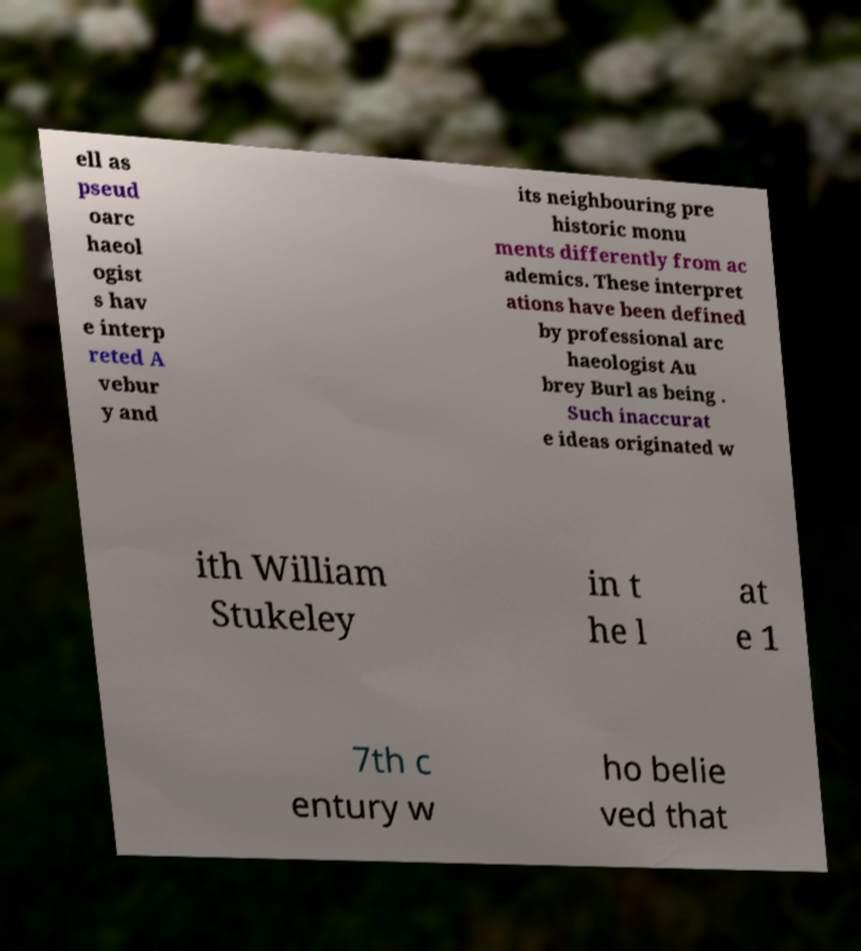Can you read and provide the text displayed in the image?This photo seems to have some interesting text. Can you extract and type it out for me? ell as pseud oarc haeol ogist s hav e interp reted A vebur y and its neighbouring pre historic monu ments differently from ac ademics. These interpret ations have been defined by professional arc haeologist Au brey Burl as being . Such inaccurat e ideas originated w ith William Stukeley in t he l at e 1 7th c entury w ho belie ved that 